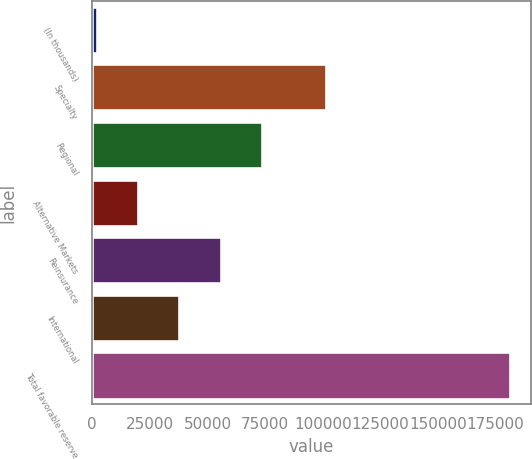Convert chart to OTSL. <chart><loc_0><loc_0><loc_500><loc_500><bar_chart><fcel>(In thousands)<fcel>Specialty<fcel>Regional<fcel>Alternative Markets<fcel>Reinsurance<fcel>International<fcel>Total favorable reserve<nl><fcel>2011<fcel>101397<fcel>73719.4<fcel>19938.1<fcel>55792.3<fcel>37865.2<fcel>181282<nl></chart> 